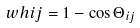Convert formula to latex. <formula><loc_0><loc_0><loc_500><loc_500>\ w h { i } { j } = 1 - \cos \Theta _ { i j }</formula> 